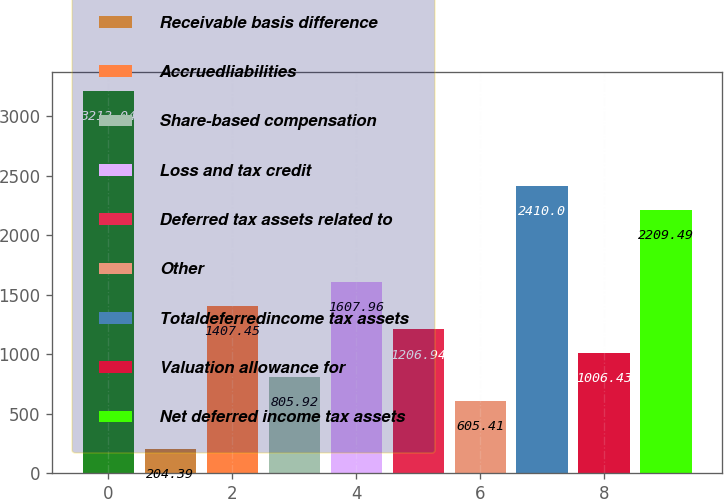Convert chart to OTSL. <chart><loc_0><loc_0><loc_500><loc_500><bar_chart><fcel>(in millions)<fcel>Receivable basis difference<fcel>Accruedliabilities<fcel>Share-based compensation<fcel>Loss and tax credit<fcel>Deferred tax assets related to<fcel>Other<fcel>Totaldeferredincome tax assets<fcel>Valuation allowance for<fcel>Net deferred income tax assets<nl><fcel>3212.04<fcel>204.39<fcel>1407.45<fcel>805.92<fcel>1607.96<fcel>1206.94<fcel>605.41<fcel>2410<fcel>1006.43<fcel>2209.49<nl></chart> 